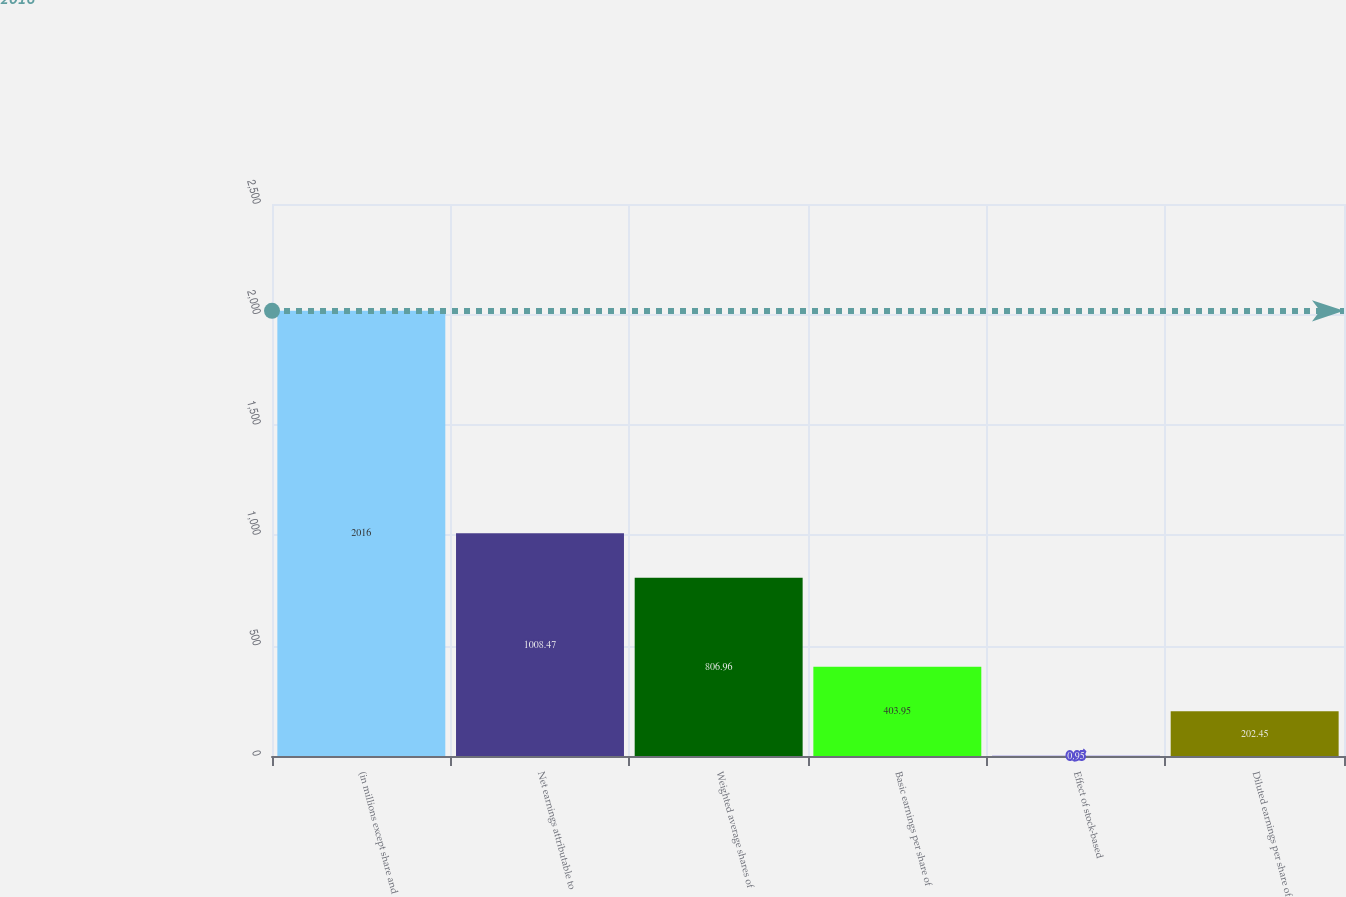Convert chart. <chart><loc_0><loc_0><loc_500><loc_500><bar_chart><fcel>(in millions except share and<fcel>Net earnings attributable to<fcel>Weighted average shares of<fcel>Basic earnings per share of<fcel>Effect of stock-based<fcel>Diluted earnings per share of<nl><fcel>2016<fcel>1008.47<fcel>806.96<fcel>403.95<fcel>0.95<fcel>202.45<nl></chart> 